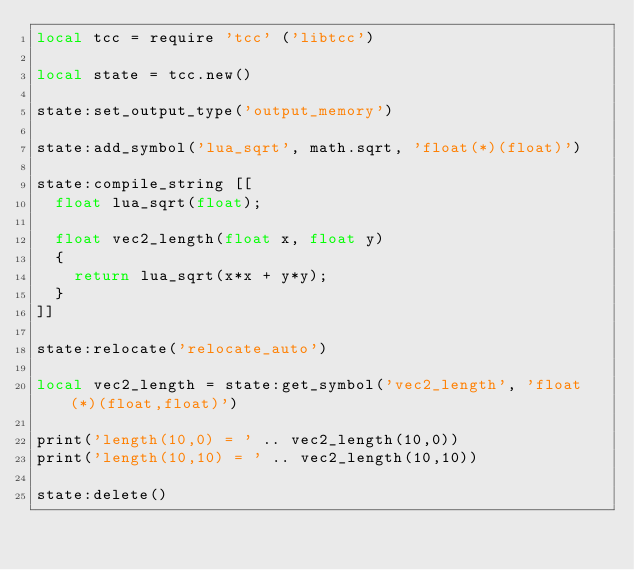<code> <loc_0><loc_0><loc_500><loc_500><_Lua_>local tcc = require 'tcc' ('libtcc')

local state = tcc.new()

state:set_output_type('output_memory')

state:add_symbol('lua_sqrt', math.sqrt, 'float(*)(float)')

state:compile_string [[
  float lua_sqrt(float);

  float vec2_length(float x, float y)
  {
    return lua_sqrt(x*x + y*y);
  }
]]

state:relocate('relocate_auto')

local vec2_length = state:get_symbol('vec2_length', 'float(*)(float,float)')

print('length(10,0) = ' .. vec2_length(10,0))
print('length(10,10) = ' .. vec2_length(10,10))

state:delete()
</code> 